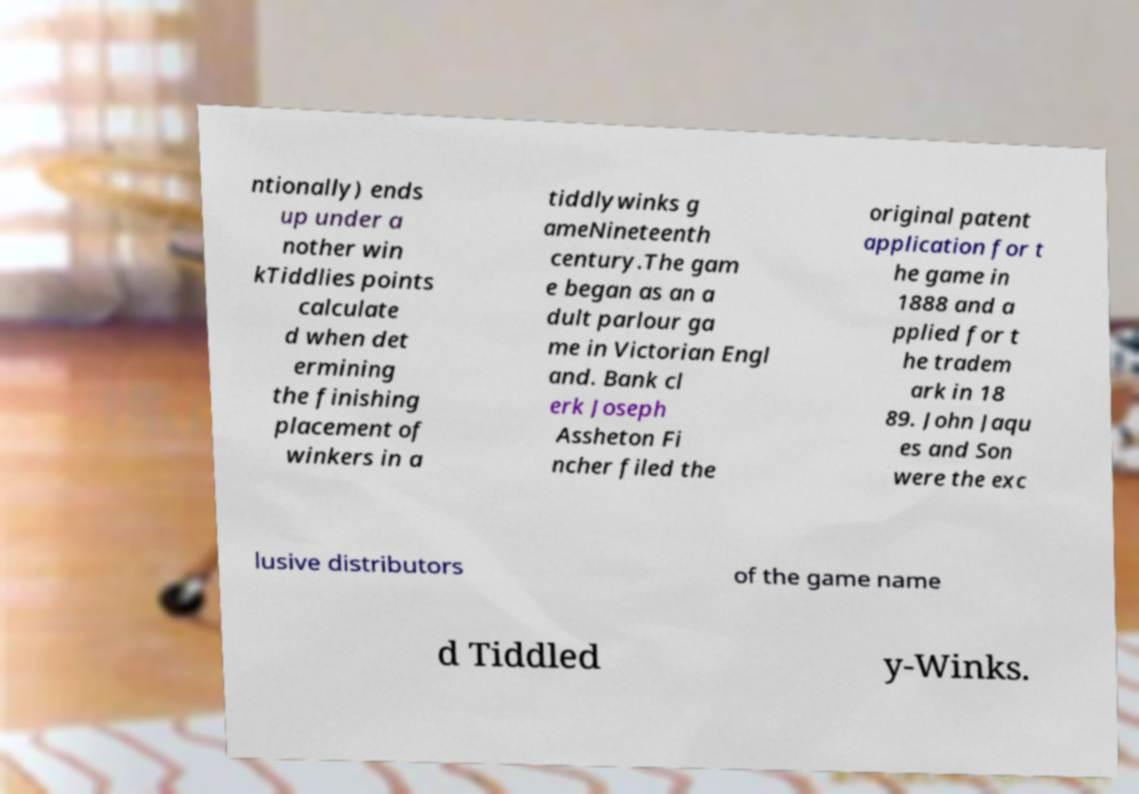I need the written content from this picture converted into text. Can you do that? ntionally) ends up under a nother win kTiddlies points calculate d when det ermining the finishing placement of winkers in a tiddlywinks g ameNineteenth century.The gam e began as an a dult parlour ga me in Victorian Engl and. Bank cl erk Joseph Assheton Fi ncher filed the original patent application for t he game in 1888 and a pplied for t he tradem ark in 18 89. John Jaqu es and Son were the exc lusive distributors of the game name d Tiddled y-Winks. 